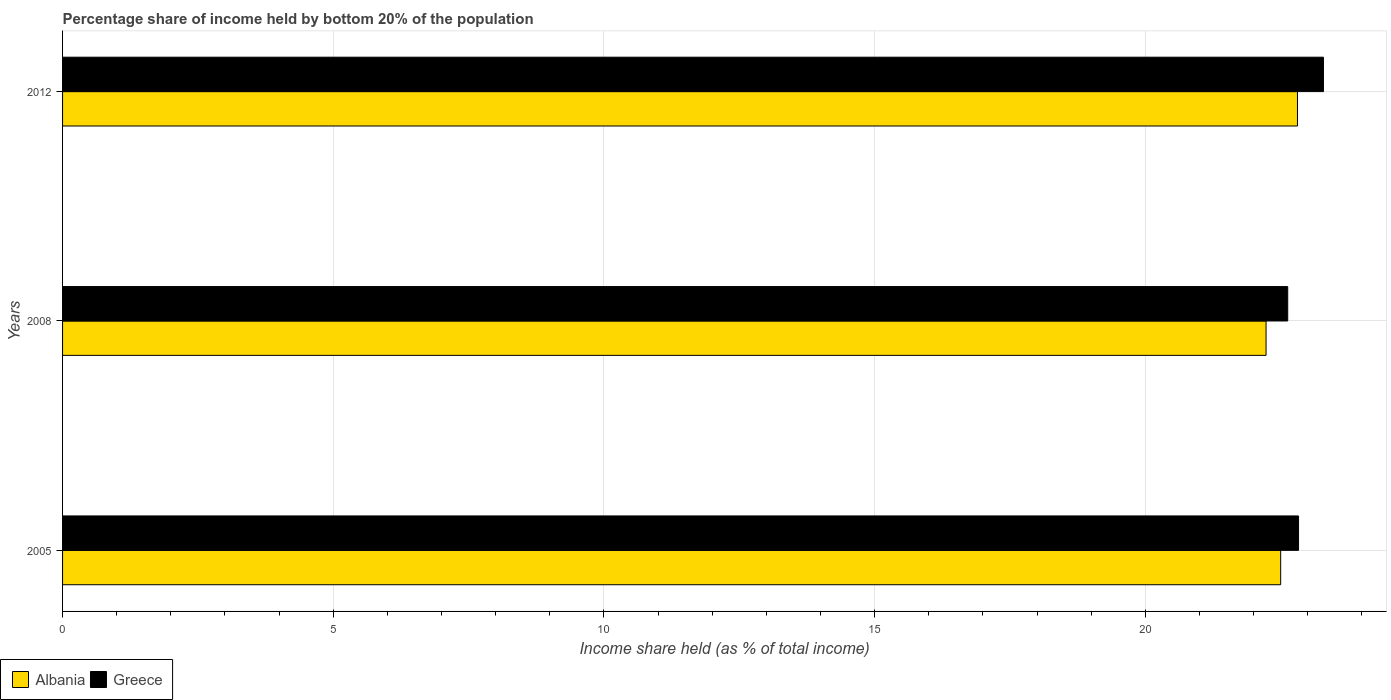How many different coloured bars are there?
Ensure brevity in your answer.  2. How many groups of bars are there?
Keep it short and to the point. 3. Are the number of bars per tick equal to the number of legend labels?
Offer a terse response. Yes. Are the number of bars on each tick of the Y-axis equal?
Your answer should be very brief. Yes. How many bars are there on the 2nd tick from the top?
Give a very brief answer. 2. How many bars are there on the 1st tick from the bottom?
Offer a terse response. 2. In how many cases, is the number of bars for a given year not equal to the number of legend labels?
Your answer should be compact. 0. What is the share of income held by bottom 20% of the population in Greece in 2005?
Offer a terse response. 22.83. Across all years, what is the maximum share of income held by bottom 20% of the population in Albania?
Ensure brevity in your answer.  22.81. Across all years, what is the minimum share of income held by bottom 20% of the population in Greece?
Offer a very short reply. 22.63. In which year was the share of income held by bottom 20% of the population in Albania minimum?
Make the answer very short. 2008. What is the total share of income held by bottom 20% of the population in Greece in the graph?
Provide a succinct answer. 68.75. What is the difference between the share of income held by bottom 20% of the population in Greece in 2005 and that in 2012?
Offer a very short reply. -0.46. What is the difference between the share of income held by bottom 20% of the population in Albania in 2008 and the share of income held by bottom 20% of the population in Greece in 2012?
Your response must be concise. -1.06. What is the average share of income held by bottom 20% of the population in Albania per year?
Your response must be concise. 22.51. In the year 2008, what is the difference between the share of income held by bottom 20% of the population in Greece and share of income held by bottom 20% of the population in Albania?
Your answer should be compact. 0.4. In how many years, is the share of income held by bottom 20% of the population in Albania greater than 4 %?
Offer a terse response. 3. What is the ratio of the share of income held by bottom 20% of the population in Greece in 2005 to that in 2012?
Keep it short and to the point. 0.98. Is the difference between the share of income held by bottom 20% of the population in Greece in 2005 and 2012 greater than the difference between the share of income held by bottom 20% of the population in Albania in 2005 and 2012?
Offer a very short reply. No. What is the difference between the highest and the second highest share of income held by bottom 20% of the population in Greece?
Make the answer very short. 0.46. What is the difference between the highest and the lowest share of income held by bottom 20% of the population in Greece?
Your answer should be compact. 0.66. Is the sum of the share of income held by bottom 20% of the population in Greece in 2008 and 2012 greater than the maximum share of income held by bottom 20% of the population in Albania across all years?
Give a very brief answer. Yes. What does the 2nd bar from the top in 2005 represents?
Your answer should be very brief. Albania. How many years are there in the graph?
Your answer should be very brief. 3. Are the values on the major ticks of X-axis written in scientific E-notation?
Offer a terse response. No. Does the graph contain any zero values?
Offer a very short reply. No. What is the title of the graph?
Provide a succinct answer. Percentage share of income held by bottom 20% of the population. What is the label or title of the X-axis?
Offer a very short reply. Income share held (as % of total income). What is the Income share held (as % of total income) of Greece in 2005?
Make the answer very short. 22.83. What is the Income share held (as % of total income) in Albania in 2008?
Provide a succinct answer. 22.23. What is the Income share held (as % of total income) of Greece in 2008?
Keep it short and to the point. 22.63. What is the Income share held (as % of total income) in Albania in 2012?
Offer a terse response. 22.81. What is the Income share held (as % of total income) in Greece in 2012?
Offer a terse response. 23.29. Across all years, what is the maximum Income share held (as % of total income) of Albania?
Provide a succinct answer. 22.81. Across all years, what is the maximum Income share held (as % of total income) of Greece?
Offer a very short reply. 23.29. Across all years, what is the minimum Income share held (as % of total income) in Albania?
Provide a succinct answer. 22.23. Across all years, what is the minimum Income share held (as % of total income) in Greece?
Make the answer very short. 22.63. What is the total Income share held (as % of total income) of Albania in the graph?
Offer a terse response. 67.54. What is the total Income share held (as % of total income) in Greece in the graph?
Your response must be concise. 68.75. What is the difference between the Income share held (as % of total income) in Albania in 2005 and that in 2008?
Make the answer very short. 0.27. What is the difference between the Income share held (as % of total income) of Albania in 2005 and that in 2012?
Provide a short and direct response. -0.31. What is the difference between the Income share held (as % of total income) of Greece in 2005 and that in 2012?
Your answer should be very brief. -0.46. What is the difference between the Income share held (as % of total income) in Albania in 2008 and that in 2012?
Make the answer very short. -0.58. What is the difference between the Income share held (as % of total income) of Greece in 2008 and that in 2012?
Offer a very short reply. -0.66. What is the difference between the Income share held (as % of total income) of Albania in 2005 and the Income share held (as % of total income) of Greece in 2008?
Make the answer very short. -0.13. What is the difference between the Income share held (as % of total income) in Albania in 2005 and the Income share held (as % of total income) in Greece in 2012?
Keep it short and to the point. -0.79. What is the difference between the Income share held (as % of total income) in Albania in 2008 and the Income share held (as % of total income) in Greece in 2012?
Offer a very short reply. -1.06. What is the average Income share held (as % of total income) of Albania per year?
Ensure brevity in your answer.  22.51. What is the average Income share held (as % of total income) of Greece per year?
Your answer should be compact. 22.92. In the year 2005, what is the difference between the Income share held (as % of total income) of Albania and Income share held (as % of total income) of Greece?
Provide a succinct answer. -0.33. In the year 2008, what is the difference between the Income share held (as % of total income) of Albania and Income share held (as % of total income) of Greece?
Provide a short and direct response. -0.4. In the year 2012, what is the difference between the Income share held (as % of total income) of Albania and Income share held (as % of total income) of Greece?
Make the answer very short. -0.48. What is the ratio of the Income share held (as % of total income) in Albania in 2005 to that in 2008?
Provide a short and direct response. 1.01. What is the ratio of the Income share held (as % of total income) of Greece in 2005 to that in 2008?
Ensure brevity in your answer.  1.01. What is the ratio of the Income share held (as % of total income) of Albania in 2005 to that in 2012?
Give a very brief answer. 0.99. What is the ratio of the Income share held (as % of total income) in Greece in 2005 to that in 2012?
Offer a terse response. 0.98. What is the ratio of the Income share held (as % of total income) in Albania in 2008 to that in 2012?
Provide a short and direct response. 0.97. What is the ratio of the Income share held (as % of total income) of Greece in 2008 to that in 2012?
Your answer should be very brief. 0.97. What is the difference between the highest and the second highest Income share held (as % of total income) of Albania?
Give a very brief answer. 0.31. What is the difference between the highest and the second highest Income share held (as % of total income) in Greece?
Make the answer very short. 0.46. What is the difference between the highest and the lowest Income share held (as % of total income) of Albania?
Your answer should be compact. 0.58. What is the difference between the highest and the lowest Income share held (as % of total income) of Greece?
Offer a very short reply. 0.66. 